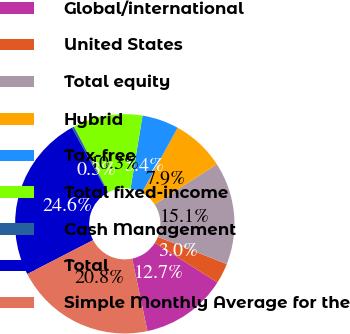Convert chart. <chart><loc_0><loc_0><loc_500><loc_500><pie_chart><fcel>Global/international<fcel>United States<fcel>Total equity<fcel>Hybrid<fcel>Tax-free<fcel>Total fixed-income<fcel>Cash Management<fcel>Total<fcel>Simple Monthly Average for the<nl><fcel>12.7%<fcel>3.0%<fcel>15.12%<fcel>7.85%<fcel>5.42%<fcel>10.27%<fcel>0.32%<fcel>24.57%<fcel>20.75%<nl></chart> 